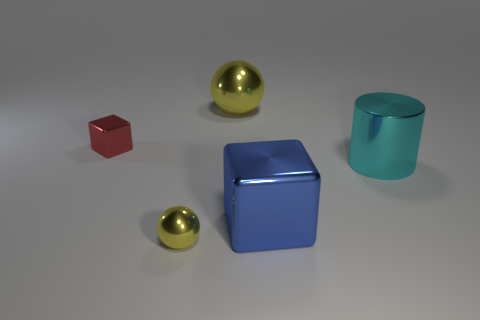Add 2 big blue matte objects. How many objects exist? 7 Subtract all blocks. How many objects are left? 3 Subtract all yellow cylinders. Subtract all blue blocks. How many cylinders are left? 1 Subtract all small red objects. Subtract all big green shiny spheres. How many objects are left? 4 Add 4 yellow metal objects. How many yellow metal objects are left? 6 Add 5 small metallic cubes. How many small metallic cubes exist? 6 Subtract 0 green cubes. How many objects are left? 5 